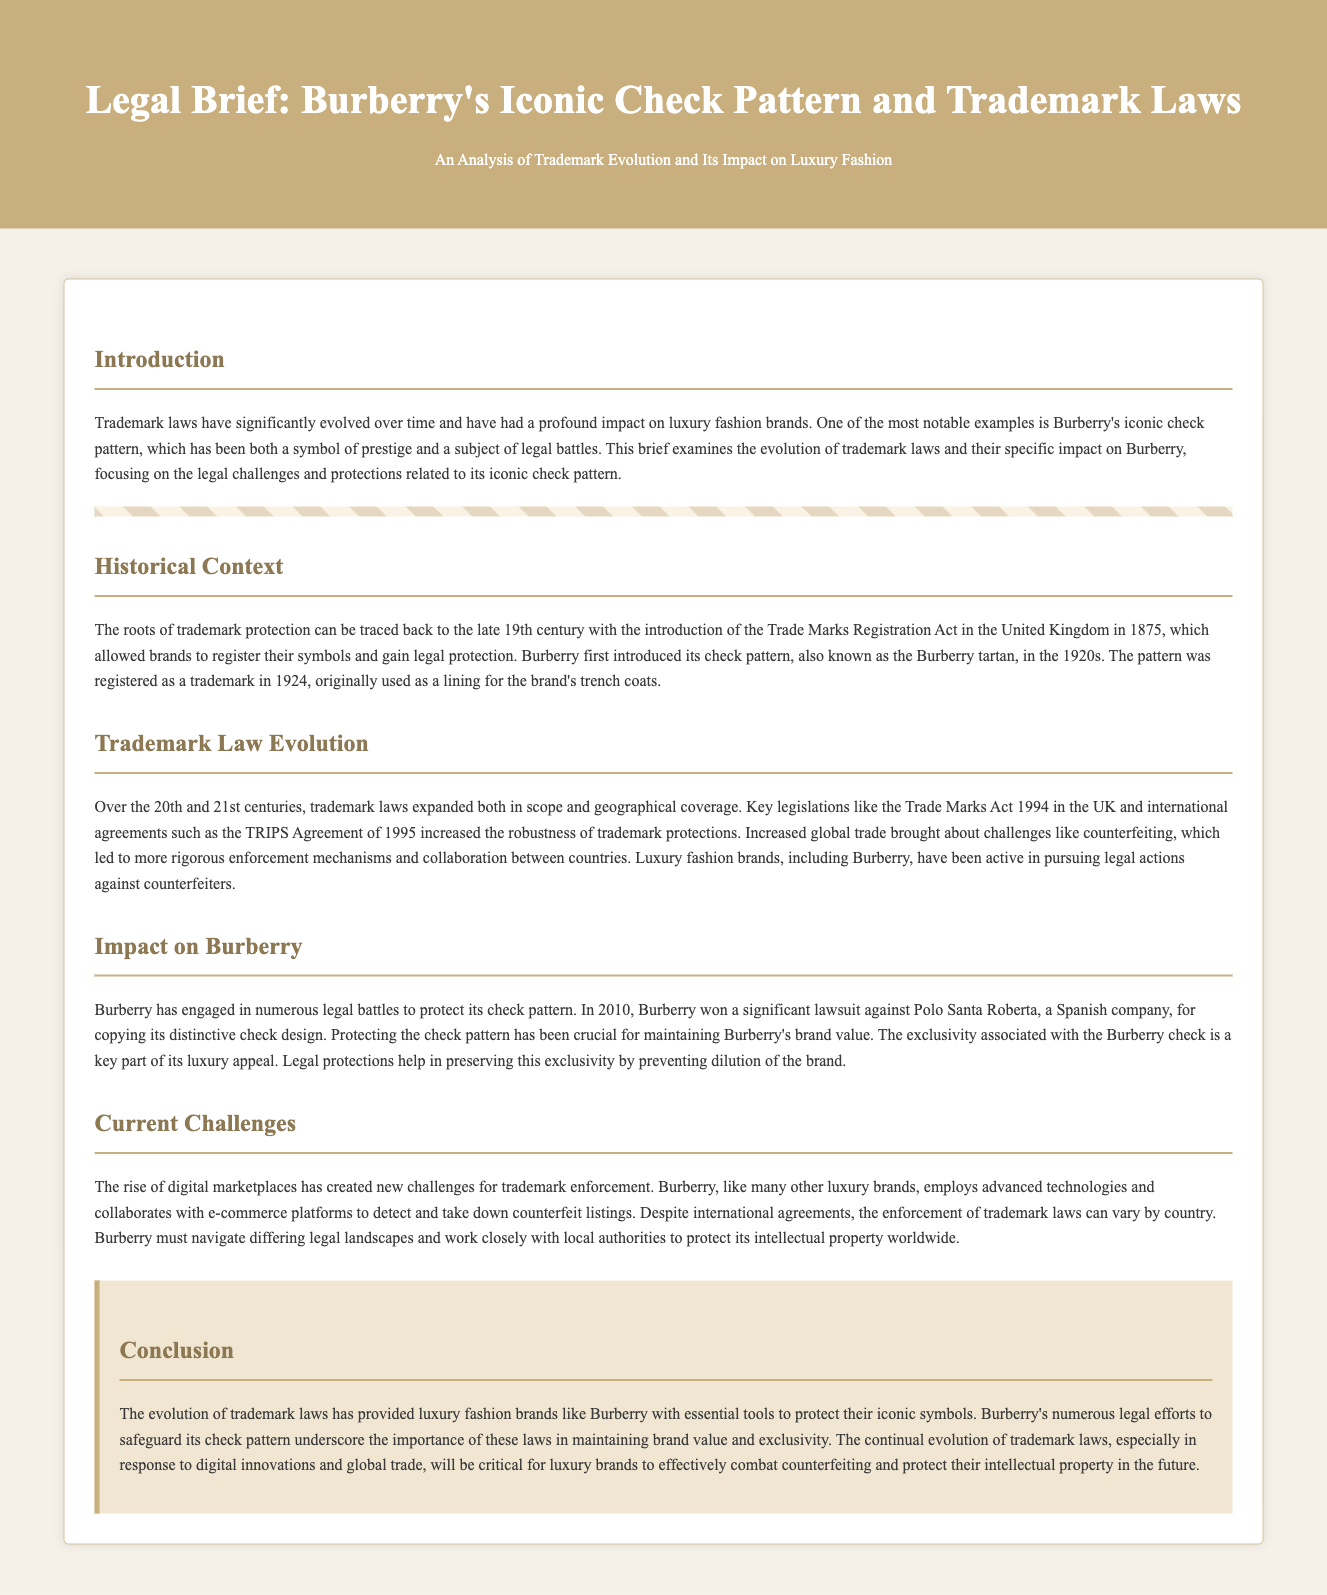What year did Burberry introduce its check pattern? The document states that Burberry first introduced its check pattern in the 1920s, with a specific mention that the pattern was registered as a trademark in 1924.
Answer: 1924 What was the primary use of Burberry's check pattern when it was first introduced? The brief explains that the check pattern was originally used as a lining for the brand's trench coats.
Answer: Lining for trench coats What key legislation expanded trademark laws in the UK? The document mentions the Trade Marks Act 1994 as a significant piece of legislation that expanded trademark laws.
Answer: Trade Marks Act 1994 Which company did Burberry win a lawsuit against in 2010? The brief notes that Burberry won a lawsuit against Polo Santa Roberta in 2010 for copying its distinctive check design.
Answer: Polo Santa Roberta What is a current challenge for trademark enforcement mentioned in the document? The rise of digital marketplaces is identified as a current challenge for trademark enforcement in the brief.
Answer: Digital marketplaces Why is protecting the check pattern crucial for Burberry? The brief states that protecting the check pattern is crucial for maintaining Burberry's brand value and exclusivity.
Answer: Brand value and exclusivity What international agreement was highlighted in the document? The TRIPS Agreement of 1995 is mentioned as an important international agreement related to trademark protections.
Answer: TRIPS Agreement What role do technologies play for Burberry in terms of trademark enforcement? The document explains that Burberry employs advanced technologies to detect and take down counterfeit listings.
Answer: Detecting counterfeit listings 